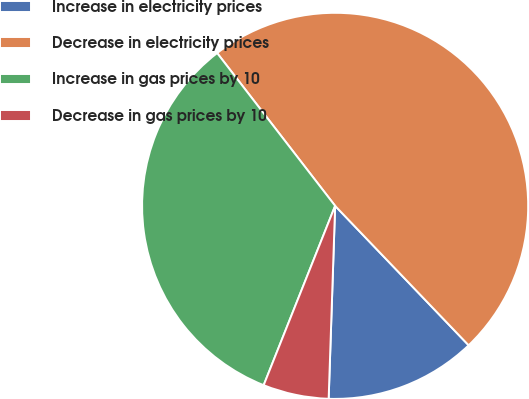Convert chart to OTSL. <chart><loc_0><loc_0><loc_500><loc_500><pie_chart><fcel>Increase in electricity prices<fcel>Decrease in electricity prices<fcel>Increase in gas prices by 10<fcel>Decrease in gas prices by 10<nl><fcel>12.69%<fcel>48.31%<fcel>33.5%<fcel>5.5%<nl></chart> 